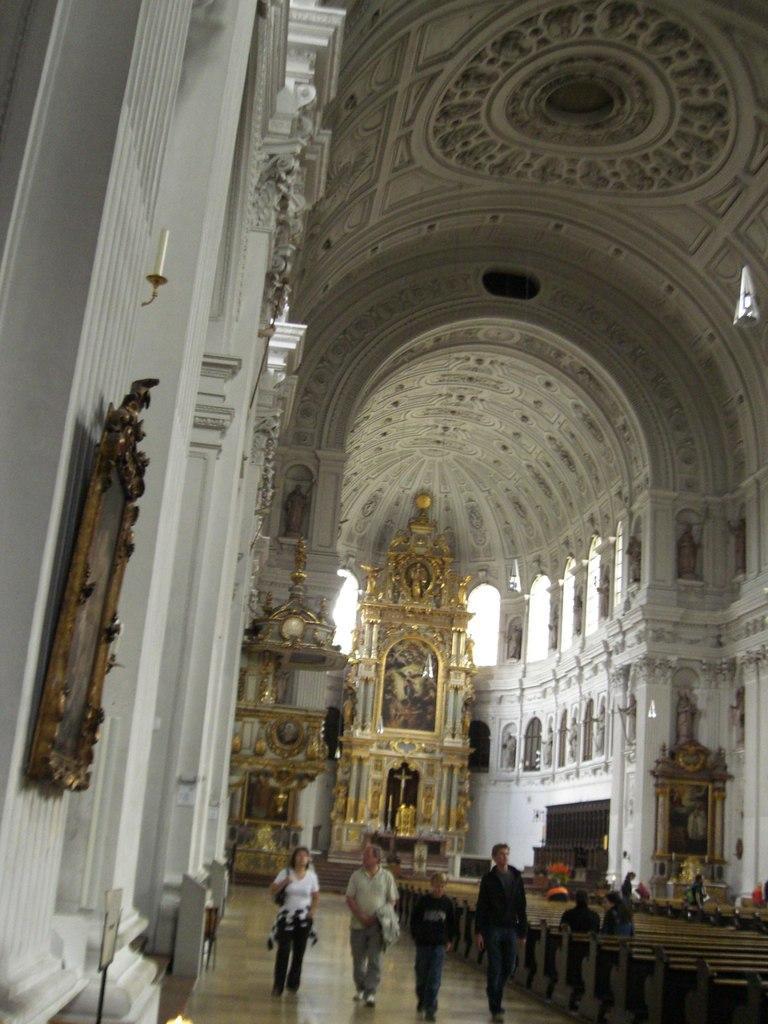Describe this image in one or two sentences. In this picture I can see the inside view of a building, there are group of people, there are benches, boards, there are frames attached to the walls and there are sculptures. 